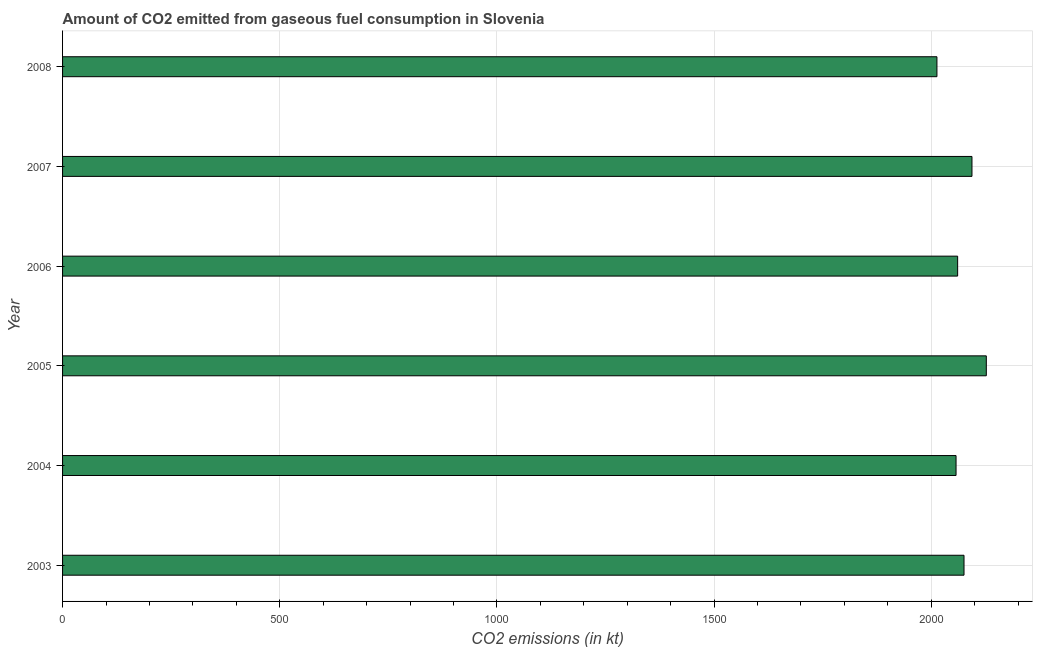Does the graph contain grids?
Make the answer very short. Yes. What is the title of the graph?
Keep it short and to the point. Amount of CO2 emitted from gaseous fuel consumption in Slovenia. What is the label or title of the X-axis?
Make the answer very short. CO2 emissions (in kt). What is the label or title of the Y-axis?
Give a very brief answer. Year. What is the co2 emissions from gaseous fuel consumption in 2008?
Your answer should be compact. 2013.18. Across all years, what is the maximum co2 emissions from gaseous fuel consumption?
Ensure brevity in your answer.  2126.86. Across all years, what is the minimum co2 emissions from gaseous fuel consumption?
Keep it short and to the point. 2013.18. In which year was the co2 emissions from gaseous fuel consumption maximum?
Provide a short and direct response. 2005. In which year was the co2 emissions from gaseous fuel consumption minimum?
Your answer should be compact. 2008. What is the sum of the co2 emissions from gaseous fuel consumption?
Offer a very short reply. 1.24e+04. What is the difference between the co2 emissions from gaseous fuel consumption in 2004 and 2008?
Your response must be concise. 44. What is the average co2 emissions from gaseous fuel consumption per year?
Give a very brief answer. 2071.24. What is the median co2 emissions from gaseous fuel consumption?
Provide a short and direct response. 2068.19. Do a majority of the years between 2008 and 2007 (inclusive) have co2 emissions from gaseous fuel consumption greater than 1800 kt?
Make the answer very short. No. What is the ratio of the co2 emissions from gaseous fuel consumption in 2006 to that in 2008?
Offer a terse response. 1.02. Is the co2 emissions from gaseous fuel consumption in 2003 less than that in 2008?
Provide a succinct answer. No. Is the difference between the co2 emissions from gaseous fuel consumption in 2003 and 2005 greater than the difference between any two years?
Give a very brief answer. No. What is the difference between the highest and the second highest co2 emissions from gaseous fuel consumption?
Your response must be concise. 33. Is the sum of the co2 emissions from gaseous fuel consumption in 2003 and 2007 greater than the maximum co2 emissions from gaseous fuel consumption across all years?
Offer a terse response. Yes. What is the difference between the highest and the lowest co2 emissions from gaseous fuel consumption?
Ensure brevity in your answer.  113.68. How many bars are there?
Offer a very short reply. 6. Are all the bars in the graph horizontal?
Your response must be concise. Yes. Are the values on the major ticks of X-axis written in scientific E-notation?
Offer a very short reply. No. What is the CO2 emissions (in kt) of 2003?
Provide a short and direct response. 2075.52. What is the CO2 emissions (in kt) in 2004?
Ensure brevity in your answer.  2057.19. What is the CO2 emissions (in kt) in 2005?
Offer a very short reply. 2126.86. What is the CO2 emissions (in kt) in 2006?
Provide a short and direct response. 2060.85. What is the CO2 emissions (in kt) of 2007?
Give a very brief answer. 2093.86. What is the CO2 emissions (in kt) in 2008?
Give a very brief answer. 2013.18. What is the difference between the CO2 emissions (in kt) in 2003 and 2004?
Keep it short and to the point. 18.34. What is the difference between the CO2 emissions (in kt) in 2003 and 2005?
Ensure brevity in your answer.  -51.34. What is the difference between the CO2 emissions (in kt) in 2003 and 2006?
Offer a terse response. 14.67. What is the difference between the CO2 emissions (in kt) in 2003 and 2007?
Keep it short and to the point. -18.34. What is the difference between the CO2 emissions (in kt) in 2003 and 2008?
Give a very brief answer. 62.34. What is the difference between the CO2 emissions (in kt) in 2004 and 2005?
Give a very brief answer. -69.67. What is the difference between the CO2 emissions (in kt) in 2004 and 2006?
Give a very brief answer. -3.67. What is the difference between the CO2 emissions (in kt) in 2004 and 2007?
Make the answer very short. -36.67. What is the difference between the CO2 emissions (in kt) in 2004 and 2008?
Keep it short and to the point. 44. What is the difference between the CO2 emissions (in kt) in 2005 and 2006?
Ensure brevity in your answer.  66.01. What is the difference between the CO2 emissions (in kt) in 2005 and 2007?
Make the answer very short. 33. What is the difference between the CO2 emissions (in kt) in 2005 and 2008?
Ensure brevity in your answer.  113.68. What is the difference between the CO2 emissions (in kt) in 2006 and 2007?
Give a very brief answer. -33. What is the difference between the CO2 emissions (in kt) in 2006 and 2008?
Your answer should be compact. 47.67. What is the difference between the CO2 emissions (in kt) in 2007 and 2008?
Make the answer very short. 80.67. What is the ratio of the CO2 emissions (in kt) in 2003 to that in 2006?
Offer a terse response. 1.01. What is the ratio of the CO2 emissions (in kt) in 2003 to that in 2008?
Keep it short and to the point. 1.03. What is the ratio of the CO2 emissions (in kt) in 2004 to that in 2006?
Keep it short and to the point. 1. What is the ratio of the CO2 emissions (in kt) in 2004 to that in 2007?
Offer a very short reply. 0.98. What is the ratio of the CO2 emissions (in kt) in 2005 to that in 2006?
Your answer should be compact. 1.03. What is the ratio of the CO2 emissions (in kt) in 2005 to that in 2007?
Provide a short and direct response. 1.02. What is the ratio of the CO2 emissions (in kt) in 2005 to that in 2008?
Your answer should be very brief. 1.06. What is the ratio of the CO2 emissions (in kt) in 2007 to that in 2008?
Your response must be concise. 1.04. 